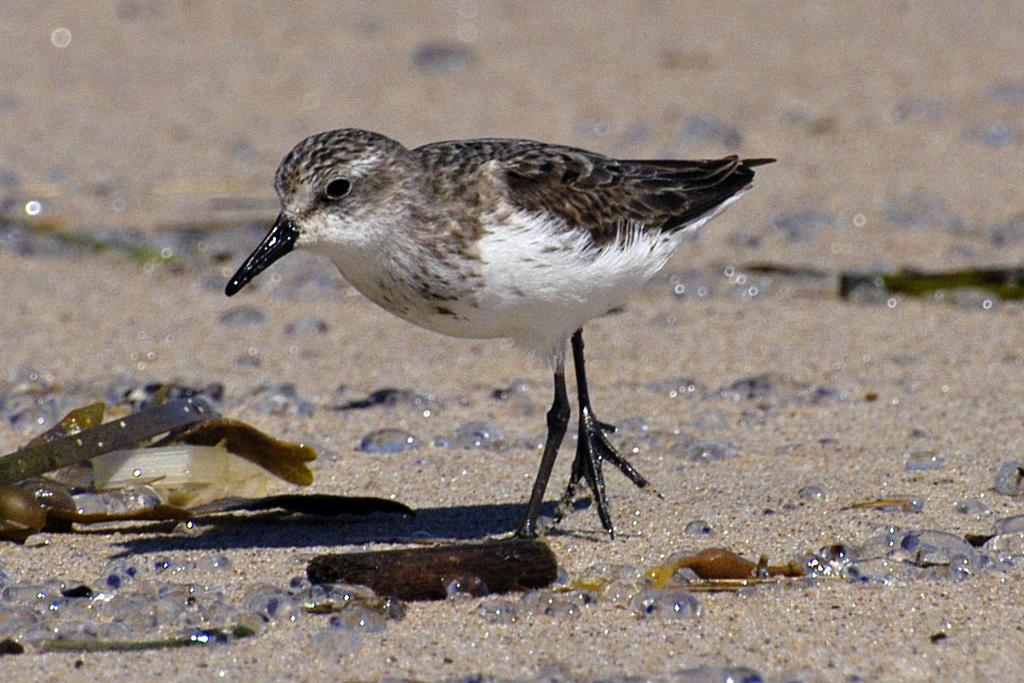What type of animal is present in the image? There is a bird in the image. What can be seen on the bird or around it in the image? There are water drops visible in the image. What type of objects are made of plastic in the image? There are plastic objects in the image. What type of oil is being used by the bird in the image? There is no oil present in the image, and the bird is not using any oil. 